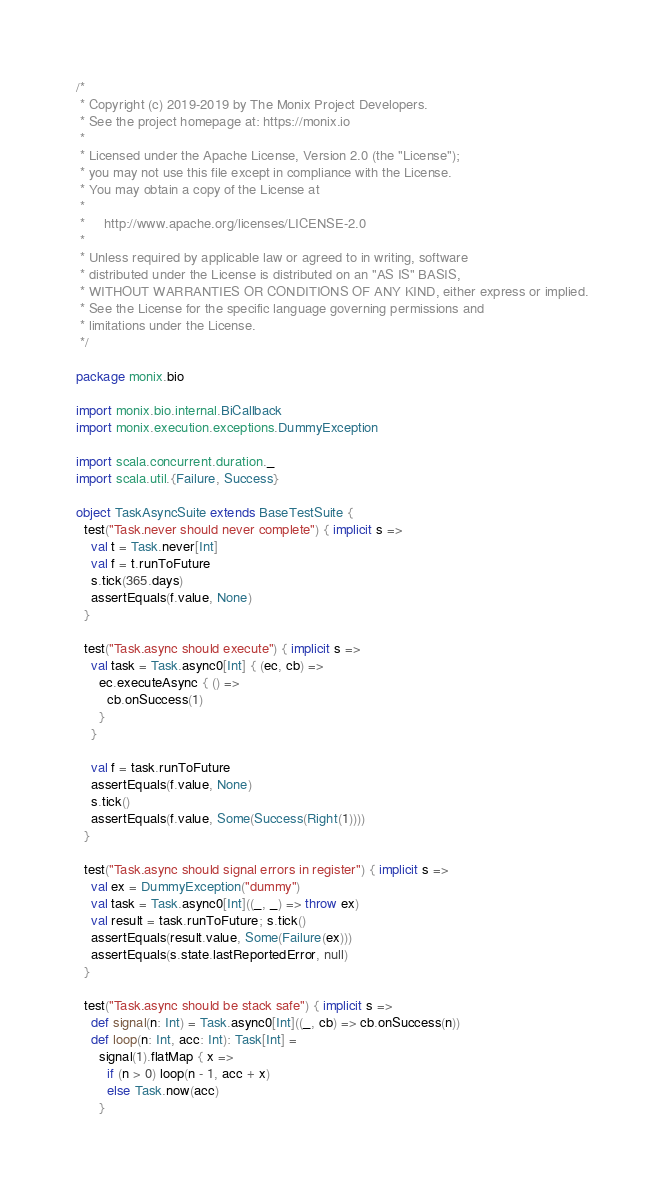Convert code to text. <code><loc_0><loc_0><loc_500><loc_500><_Scala_>/*
 * Copyright (c) 2019-2019 by The Monix Project Developers.
 * See the project homepage at: https://monix.io
 *
 * Licensed under the Apache License, Version 2.0 (the "License");
 * you may not use this file except in compliance with the License.
 * You may obtain a copy of the License at
 *
 *     http://www.apache.org/licenses/LICENSE-2.0
 *
 * Unless required by applicable law or agreed to in writing, software
 * distributed under the License is distributed on an "AS IS" BASIS,
 * WITHOUT WARRANTIES OR CONDITIONS OF ANY KIND, either express or implied.
 * See the License for the specific language governing permissions and
 * limitations under the License.
 */

package monix.bio

import monix.bio.internal.BiCallback
import monix.execution.exceptions.DummyException

import scala.concurrent.duration._
import scala.util.{Failure, Success}

object TaskAsyncSuite extends BaseTestSuite {
  test("Task.never should never complete") { implicit s =>
    val t = Task.never[Int]
    val f = t.runToFuture
    s.tick(365.days)
    assertEquals(f.value, None)
  }

  test("Task.async should execute") { implicit s =>
    val task = Task.async0[Int] { (ec, cb) =>
      ec.executeAsync { () =>
        cb.onSuccess(1)
      }
    }

    val f = task.runToFuture
    assertEquals(f.value, None)
    s.tick()
    assertEquals(f.value, Some(Success(Right(1))))
  }

  test("Task.async should signal errors in register") { implicit s =>
    val ex = DummyException("dummy")
    val task = Task.async0[Int]((_, _) => throw ex)
    val result = task.runToFuture; s.tick()
    assertEquals(result.value, Some(Failure(ex)))
    assertEquals(s.state.lastReportedError, null)
  }

  test("Task.async should be stack safe") { implicit s =>
    def signal(n: Int) = Task.async0[Int]((_, cb) => cb.onSuccess(n))
    def loop(n: Int, acc: Int): Task[Int] =
      signal(1).flatMap { x =>
        if (n > 0) loop(n - 1, acc + x)
        else Task.now(acc)
      }
</code> 